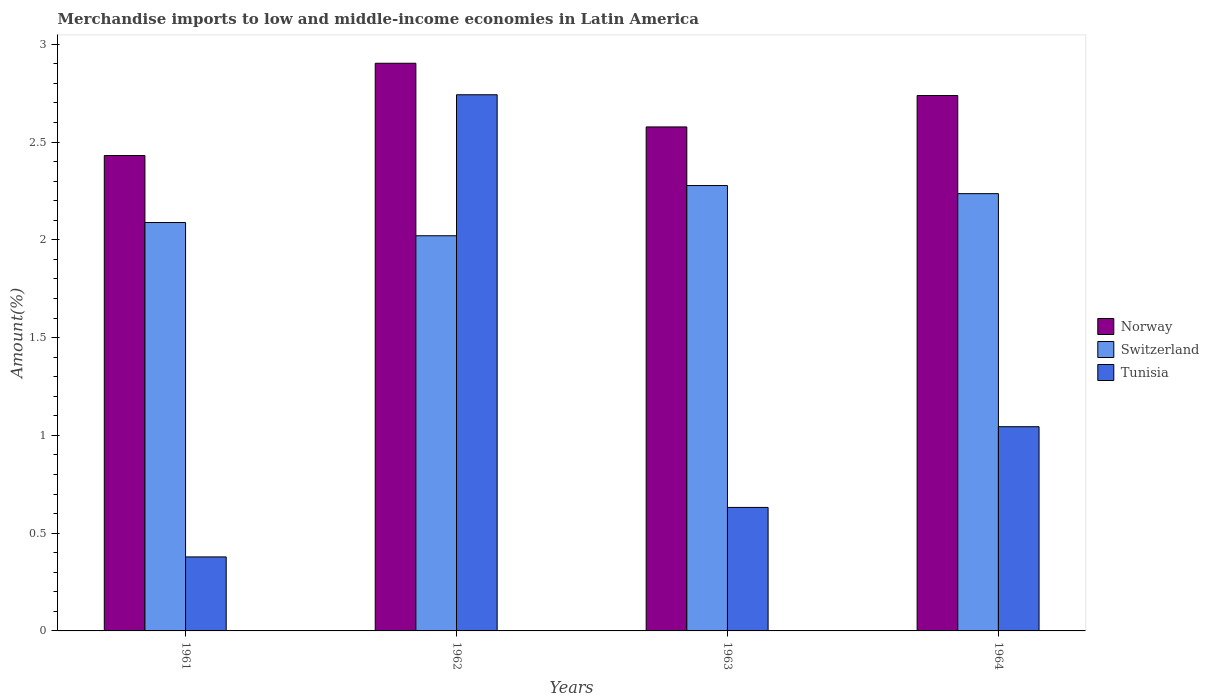How many different coloured bars are there?
Provide a short and direct response. 3. How many bars are there on the 2nd tick from the left?
Ensure brevity in your answer.  3. What is the label of the 2nd group of bars from the left?
Keep it short and to the point. 1962. What is the percentage of amount earned from merchandise imports in Tunisia in 1964?
Provide a short and direct response. 1.04. Across all years, what is the maximum percentage of amount earned from merchandise imports in Tunisia?
Keep it short and to the point. 2.74. Across all years, what is the minimum percentage of amount earned from merchandise imports in Switzerland?
Your response must be concise. 2.02. What is the total percentage of amount earned from merchandise imports in Switzerland in the graph?
Ensure brevity in your answer.  8.62. What is the difference between the percentage of amount earned from merchandise imports in Norway in 1961 and that in 1964?
Offer a terse response. -0.31. What is the difference between the percentage of amount earned from merchandise imports in Switzerland in 1961 and the percentage of amount earned from merchandise imports in Tunisia in 1964?
Provide a succinct answer. 1.04. What is the average percentage of amount earned from merchandise imports in Switzerland per year?
Your response must be concise. 2.16. In the year 1963, what is the difference between the percentage of amount earned from merchandise imports in Switzerland and percentage of amount earned from merchandise imports in Tunisia?
Offer a terse response. 1.65. In how many years, is the percentage of amount earned from merchandise imports in Tunisia greater than 1.1 %?
Your response must be concise. 1. What is the ratio of the percentage of amount earned from merchandise imports in Tunisia in 1962 to that in 1963?
Keep it short and to the point. 4.34. Is the percentage of amount earned from merchandise imports in Switzerland in 1961 less than that in 1962?
Provide a succinct answer. No. What is the difference between the highest and the second highest percentage of amount earned from merchandise imports in Switzerland?
Make the answer very short. 0.04. What is the difference between the highest and the lowest percentage of amount earned from merchandise imports in Switzerland?
Keep it short and to the point. 0.26. What does the 2nd bar from the left in 1961 represents?
Offer a very short reply. Switzerland. Are all the bars in the graph horizontal?
Offer a very short reply. No. How many years are there in the graph?
Provide a succinct answer. 4. What is the difference between two consecutive major ticks on the Y-axis?
Your answer should be very brief. 0.5. How are the legend labels stacked?
Your answer should be compact. Vertical. What is the title of the graph?
Provide a short and direct response. Merchandise imports to low and middle-income economies in Latin America. Does "Japan" appear as one of the legend labels in the graph?
Offer a very short reply. No. What is the label or title of the X-axis?
Offer a terse response. Years. What is the label or title of the Y-axis?
Ensure brevity in your answer.  Amount(%). What is the Amount(%) in Norway in 1961?
Offer a terse response. 2.43. What is the Amount(%) in Switzerland in 1961?
Make the answer very short. 2.09. What is the Amount(%) of Tunisia in 1961?
Ensure brevity in your answer.  0.38. What is the Amount(%) in Norway in 1962?
Keep it short and to the point. 2.9. What is the Amount(%) in Switzerland in 1962?
Provide a succinct answer. 2.02. What is the Amount(%) in Tunisia in 1962?
Provide a succinct answer. 2.74. What is the Amount(%) in Norway in 1963?
Keep it short and to the point. 2.58. What is the Amount(%) in Switzerland in 1963?
Give a very brief answer. 2.28. What is the Amount(%) in Tunisia in 1963?
Your response must be concise. 0.63. What is the Amount(%) in Norway in 1964?
Your answer should be very brief. 2.74. What is the Amount(%) of Switzerland in 1964?
Keep it short and to the point. 2.24. What is the Amount(%) of Tunisia in 1964?
Ensure brevity in your answer.  1.04. Across all years, what is the maximum Amount(%) in Norway?
Keep it short and to the point. 2.9. Across all years, what is the maximum Amount(%) of Switzerland?
Make the answer very short. 2.28. Across all years, what is the maximum Amount(%) of Tunisia?
Keep it short and to the point. 2.74. Across all years, what is the minimum Amount(%) in Norway?
Ensure brevity in your answer.  2.43. Across all years, what is the minimum Amount(%) in Switzerland?
Provide a succinct answer. 2.02. Across all years, what is the minimum Amount(%) of Tunisia?
Offer a very short reply. 0.38. What is the total Amount(%) in Norway in the graph?
Offer a very short reply. 10.65. What is the total Amount(%) in Switzerland in the graph?
Offer a very short reply. 8.62. What is the total Amount(%) of Tunisia in the graph?
Offer a very short reply. 4.8. What is the difference between the Amount(%) in Norway in 1961 and that in 1962?
Offer a terse response. -0.47. What is the difference between the Amount(%) of Switzerland in 1961 and that in 1962?
Offer a terse response. 0.07. What is the difference between the Amount(%) in Tunisia in 1961 and that in 1962?
Ensure brevity in your answer.  -2.36. What is the difference between the Amount(%) of Norway in 1961 and that in 1963?
Offer a very short reply. -0.15. What is the difference between the Amount(%) in Switzerland in 1961 and that in 1963?
Offer a terse response. -0.19. What is the difference between the Amount(%) of Tunisia in 1961 and that in 1963?
Provide a succinct answer. -0.25. What is the difference between the Amount(%) in Norway in 1961 and that in 1964?
Make the answer very short. -0.31. What is the difference between the Amount(%) of Switzerland in 1961 and that in 1964?
Provide a short and direct response. -0.15. What is the difference between the Amount(%) of Tunisia in 1961 and that in 1964?
Give a very brief answer. -0.67. What is the difference between the Amount(%) in Norway in 1962 and that in 1963?
Your response must be concise. 0.33. What is the difference between the Amount(%) in Switzerland in 1962 and that in 1963?
Provide a succinct answer. -0.26. What is the difference between the Amount(%) of Tunisia in 1962 and that in 1963?
Ensure brevity in your answer.  2.11. What is the difference between the Amount(%) in Norway in 1962 and that in 1964?
Your answer should be compact. 0.17. What is the difference between the Amount(%) of Switzerland in 1962 and that in 1964?
Give a very brief answer. -0.22. What is the difference between the Amount(%) in Tunisia in 1962 and that in 1964?
Your answer should be very brief. 1.7. What is the difference between the Amount(%) in Norway in 1963 and that in 1964?
Give a very brief answer. -0.16. What is the difference between the Amount(%) in Switzerland in 1963 and that in 1964?
Keep it short and to the point. 0.04. What is the difference between the Amount(%) in Tunisia in 1963 and that in 1964?
Your response must be concise. -0.41. What is the difference between the Amount(%) of Norway in 1961 and the Amount(%) of Switzerland in 1962?
Your answer should be compact. 0.41. What is the difference between the Amount(%) in Norway in 1961 and the Amount(%) in Tunisia in 1962?
Provide a short and direct response. -0.31. What is the difference between the Amount(%) in Switzerland in 1961 and the Amount(%) in Tunisia in 1962?
Provide a short and direct response. -0.65. What is the difference between the Amount(%) in Norway in 1961 and the Amount(%) in Switzerland in 1963?
Offer a very short reply. 0.15. What is the difference between the Amount(%) of Norway in 1961 and the Amount(%) of Tunisia in 1963?
Keep it short and to the point. 1.8. What is the difference between the Amount(%) in Switzerland in 1961 and the Amount(%) in Tunisia in 1963?
Provide a short and direct response. 1.46. What is the difference between the Amount(%) of Norway in 1961 and the Amount(%) of Switzerland in 1964?
Provide a short and direct response. 0.19. What is the difference between the Amount(%) of Norway in 1961 and the Amount(%) of Tunisia in 1964?
Your answer should be very brief. 1.39. What is the difference between the Amount(%) of Switzerland in 1961 and the Amount(%) of Tunisia in 1964?
Offer a very short reply. 1.04. What is the difference between the Amount(%) of Norway in 1962 and the Amount(%) of Switzerland in 1963?
Your answer should be very brief. 0.63. What is the difference between the Amount(%) in Norway in 1962 and the Amount(%) in Tunisia in 1963?
Your answer should be very brief. 2.27. What is the difference between the Amount(%) of Switzerland in 1962 and the Amount(%) of Tunisia in 1963?
Your answer should be compact. 1.39. What is the difference between the Amount(%) of Norway in 1962 and the Amount(%) of Switzerland in 1964?
Make the answer very short. 0.67. What is the difference between the Amount(%) of Norway in 1962 and the Amount(%) of Tunisia in 1964?
Keep it short and to the point. 1.86. What is the difference between the Amount(%) of Switzerland in 1962 and the Amount(%) of Tunisia in 1964?
Your answer should be compact. 0.98. What is the difference between the Amount(%) in Norway in 1963 and the Amount(%) in Switzerland in 1964?
Make the answer very short. 0.34. What is the difference between the Amount(%) in Norway in 1963 and the Amount(%) in Tunisia in 1964?
Provide a short and direct response. 1.53. What is the difference between the Amount(%) of Switzerland in 1963 and the Amount(%) of Tunisia in 1964?
Ensure brevity in your answer.  1.23. What is the average Amount(%) of Norway per year?
Offer a very short reply. 2.66. What is the average Amount(%) in Switzerland per year?
Make the answer very short. 2.16. What is the average Amount(%) of Tunisia per year?
Provide a succinct answer. 1.2. In the year 1961, what is the difference between the Amount(%) of Norway and Amount(%) of Switzerland?
Your response must be concise. 0.34. In the year 1961, what is the difference between the Amount(%) in Norway and Amount(%) in Tunisia?
Ensure brevity in your answer.  2.05. In the year 1961, what is the difference between the Amount(%) in Switzerland and Amount(%) in Tunisia?
Give a very brief answer. 1.71. In the year 1962, what is the difference between the Amount(%) in Norway and Amount(%) in Switzerland?
Offer a very short reply. 0.88. In the year 1962, what is the difference between the Amount(%) of Norway and Amount(%) of Tunisia?
Make the answer very short. 0.16. In the year 1962, what is the difference between the Amount(%) of Switzerland and Amount(%) of Tunisia?
Your answer should be compact. -0.72. In the year 1963, what is the difference between the Amount(%) in Norway and Amount(%) in Switzerland?
Make the answer very short. 0.3. In the year 1963, what is the difference between the Amount(%) in Norway and Amount(%) in Tunisia?
Keep it short and to the point. 1.95. In the year 1963, what is the difference between the Amount(%) of Switzerland and Amount(%) of Tunisia?
Your response must be concise. 1.65. In the year 1964, what is the difference between the Amount(%) in Norway and Amount(%) in Switzerland?
Your answer should be compact. 0.5. In the year 1964, what is the difference between the Amount(%) in Norway and Amount(%) in Tunisia?
Give a very brief answer. 1.69. In the year 1964, what is the difference between the Amount(%) of Switzerland and Amount(%) of Tunisia?
Ensure brevity in your answer.  1.19. What is the ratio of the Amount(%) of Norway in 1961 to that in 1962?
Ensure brevity in your answer.  0.84. What is the ratio of the Amount(%) in Switzerland in 1961 to that in 1962?
Provide a short and direct response. 1.03. What is the ratio of the Amount(%) in Tunisia in 1961 to that in 1962?
Give a very brief answer. 0.14. What is the ratio of the Amount(%) in Norway in 1961 to that in 1963?
Your answer should be very brief. 0.94. What is the ratio of the Amount(%) of Switzerland in 1961 to that in 1963?
Provide a succinct answer. 0.92. What is the ratio of the Amount(%) in Tunisia in 1961 to that in 1963?
Keep it short and to the point. 0.6. What is the ratio of the Amount(%) of Norway in 1961 to that in 1964?
Provide a succinct answer. 0.89. What is the ratio of the Amount(%) of Switzerland in 1961 to that in 1964?
Ensure brevity in your answer.  0.93. What is the ratio of the Amount(%) in Tunisia in 1961 to that in 1964?
Give a very brief answer. 0.36. What is the ratio of the Amount(%) in Norway in 1962 to that in 1963?
Make the answer very short. 1.13. What is the ratio of the Amount(%) in Switzerland in 1962 to that in 1963?
Keep it short and to the point. 0.89. What is the ratio of the Amount(%) in Tunisia in 1962 to that in 1963?
Ensure brevity in your answer.  4.34. What is the ratio of the Amount(%) of Norway in 1962 to that in 1964?
Offer a terse response. 1.06. What is the ratio of the Amount(%) in Switzerland in 1962 to that in 1964?
Keep it short and to the point. 0.9. What is the ratio of the Amount(%) in Tunisia in 1962 to that in 1964?
Provide a succinct answer. 2.63. What is the ratio of the Amount(%) in Norway in 1963 to that in 1964?
Ensure brevity in your answer.  0.94. What is the ratio of the Amount(%) in Switzerland in 1963 to that in 1964?
Give a very brief answer. 1.02. What is the ratio of the Amount(%) in Tunisia in 1963 to that in 1964?
Your answer should be very brief. 0.6. What is the difference between the highest and the second highest Amount(%) of Norway?
Offer a very short reply. 0.17. What is the difference between the highest and the second highest Amount(%) in Switzerland?
Make the answer very short. 0.04. What is the difference between the highest and the second highest Amount(%) of Tunisia?
Give a very brief answer. 1.7. What is the difference between the highest and the lowest Amount(%) of Norway?
Ensure brevity in your answer.  0.47. What is the difference between the highest and the lowest Amount(%) in Switzerland?
Provide a succinct answer. 0.26. What is the difference between the highest and the lowest Amount(%) in Tunisia?
Your response must be concise. 2.36. 